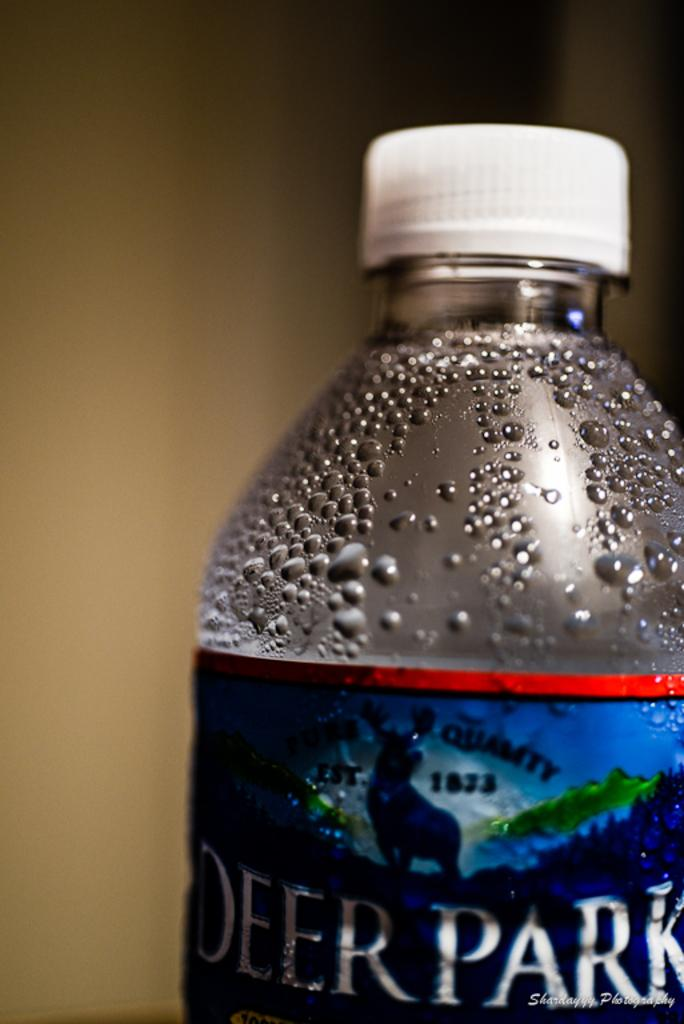<image>
Write a terse but informative summary of the picture. A bottle of Deer Park water with condensation forming at the top. 